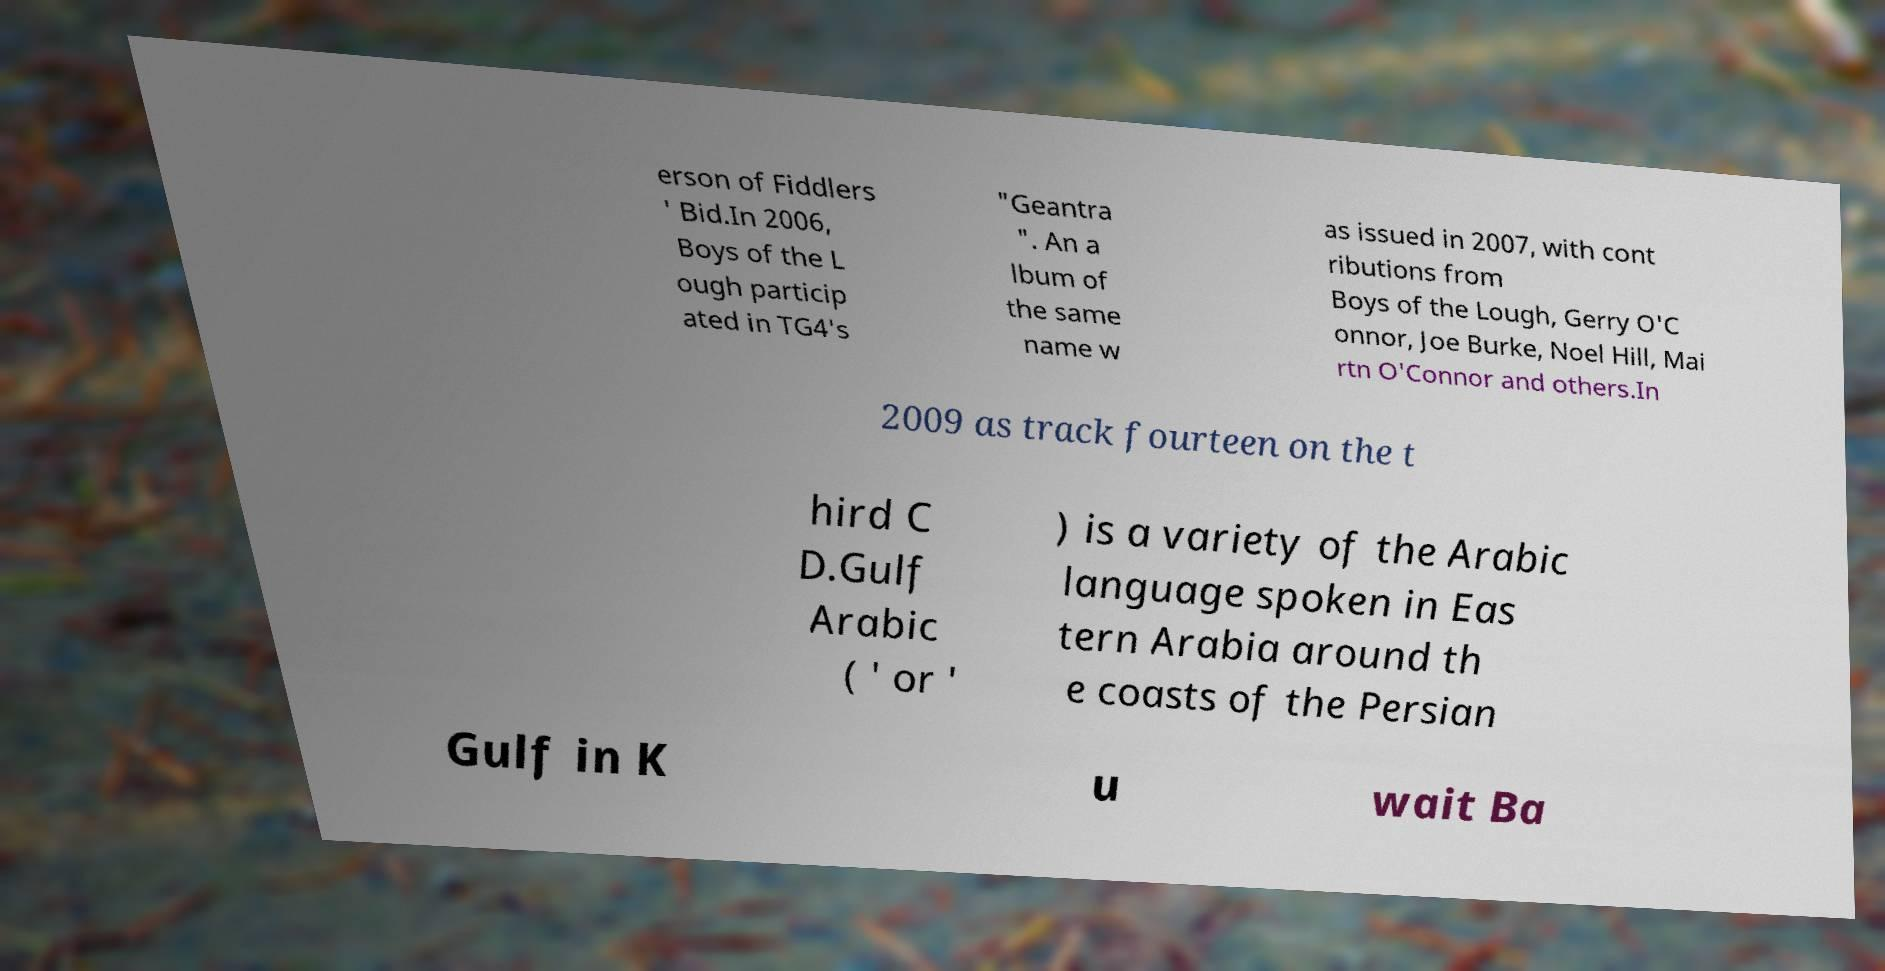There's text embedded in this image that I need extracted. Can you transcribe it verbatim? erson of Fiddlers ' Bid.In 2006, Boys of the L ough particip ated in TG4's "Geantra ". An a lbum of the same name w as issued in 2007, with cont ributions from Boys of the Lough, Gerry O'C onnor, Joe Burke, Noel Hill, Mai rtn O'Connor and others.In 2009 as track fourteen on the t hird C D.Gulf Arabic ( ' or ' ) is a variety of the Arabic language spoken in Eas tern Arabia around th e coasts of the Persian Gulf in K u wait Ba 